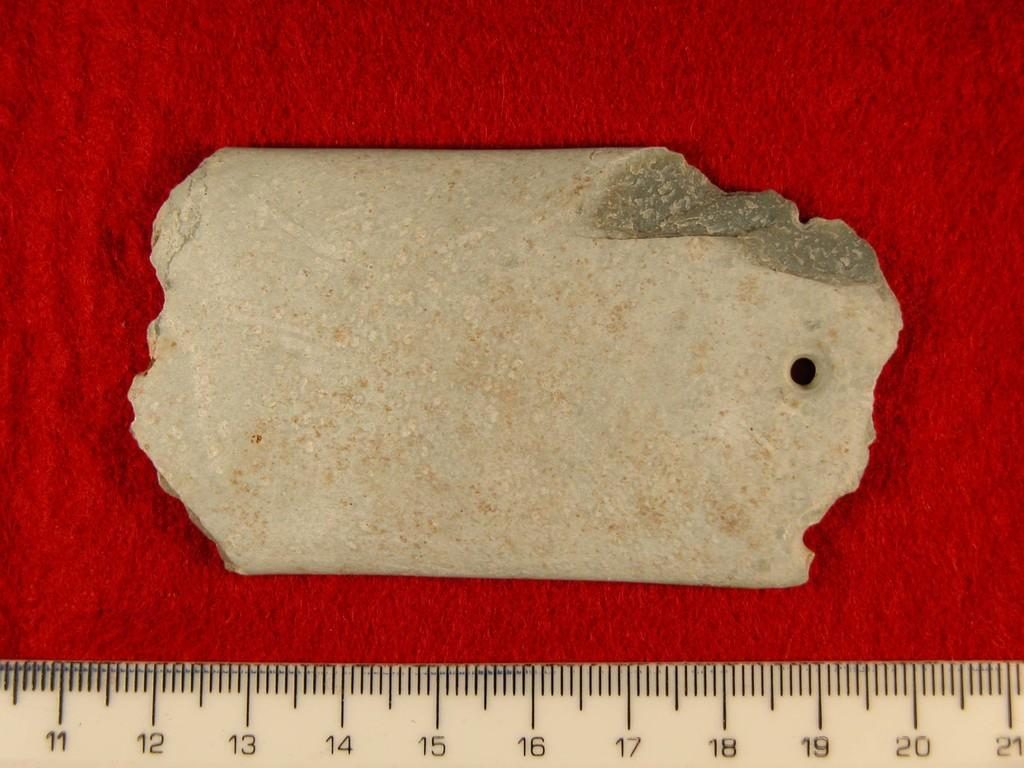What can be seen in the image? There is an object in the image. Can you describe the color of the object? The object is cream-colored. What is the object placed on? The object is placed on a red cloth. Is there any tool visible in the image? Yes, there is a measuring scale visible in the image. What language is spoken by the object in the image? The object in the image is not capable of speaking any language, as it is an inanimate object. 